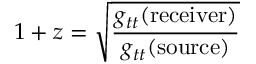Convert formula to latex. <formula><loc_0><loc_0><loc_500><loc_500>1 + z = { \sqrt { \frac { g _ { t t } ( { r e c e i v e r } ) } { g _ { t t } ( { s o u r c e } ) } } }</formula> 